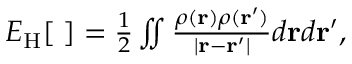Convert formula to latex. <formula><loc_0><loc_0><loc_500><loc_500>\begin{array} { r } { E _ { H } [ { \rho } ] = \frac { 1 } { 2 } \iint \frac { \rho ( { r } ) \rho ( { r ^ { \prime } } ) } { | { r - r ^ { \prime } } | } d { r } d { r ^ { \prime } } , } \end{array}</formula> 